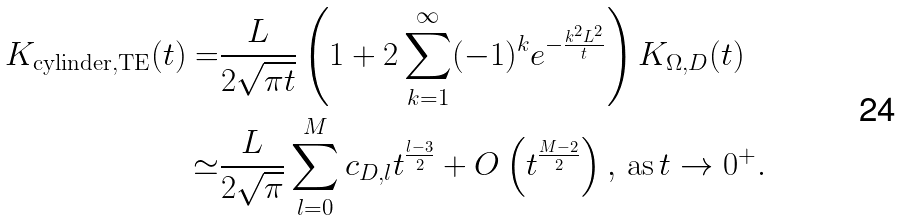<formula> <loc_0><loc_0><loc_500><loc_500>K _ { \text {cylinder} , \text {TE} } ( t ) = & \frac { L } { 2 \sqrt { \pi t } } \left ( 1 + 2 \sum _ { k = 1 } ^ { \infty } ( - 1 ) ^ { k } e ^ { - \frac { k ^ { 2 } L ^ { 2 } } { t } } \right ) K _ { \Omega , D } ( t ) \\ \simeq & \frac { L } { 2 \sqrt { \pi } } \sum _ { l = 0 } ^ { M } c _ { D , l } t ^ { \frac { l - 3 } { 2 } } + O \left ( t ^ { \frac { M - 2 } { 2 } } \right ) , \, \text {as} \, t \rightarrow 0 ^ { + } .</formula> 